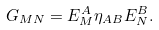<formula> <loc_0><loc_0><loc_500><loc_500>G _ { M N } = E _ { M } ^ { A } \eta _ { A B } E _ { N } ^ { B } .</formula> 